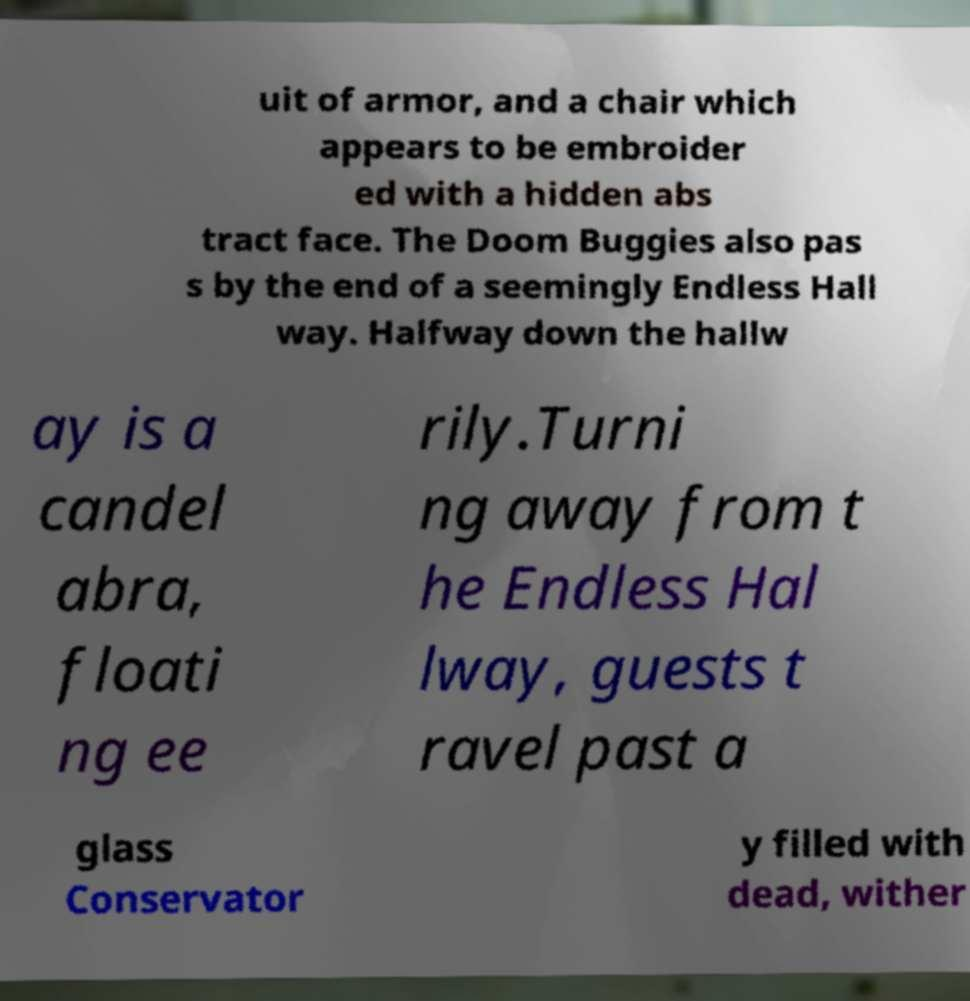Could you extract and type out the text from this image? uit of armor, and a chair which appears to be embroider ed with a hidden abs tract face. The Doom Buggies also pas s by the end of a seemingly Endless Hall way. Halfway down the hallw ay is a candel abra, floati ng ee rily.Turni ng away from t he Endless Hal lway, guests t ravel past a glass Conservator y filled with dead, wither 